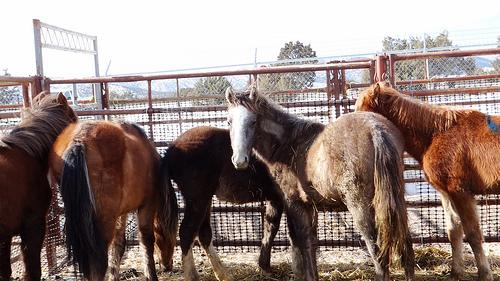Which horse has a unique mark on its back in the image? The horse with a blue mark on its back. Name two captioned colors seen on the horse in the image. Brown and white. What is the primary setting of the image, and what is the weather like? The primary setting is an enclosure with horses, and the weather is sunny with a clear sky. In the context of the image, describe what a referential expression grounding task could involve. A referential expression grounding task would involve identifying specific parts or features of the horses, such as their ears, eyes, tails, and legs, and grounding these expressions in the bounding box coordinates provided. If one would like to purchase a horse from the image, how would a product advertisement for a particular horse look like? Introducing our magnificent brown horse with a white face! This majestic creature is perfect for equestrian enthusiasts, featuring a distinct white nose and a charming demeanor. Don't miss out on this rare beauty. How many horses are in the image? There are four horses in the image. Determine whether the horses are well cared for by looking at the captions in the image. The horses seem to be well cared for, as they are described as eating hay and getting along well. Choose one of the horses from the captions and describe it in detail. One of the horses is a brown horse with a white face and a blue mark on its back. This horse has a white nose and stands in front of another horse and a fence. Identify the type of event where the horses might be present based on the image. The horses might be present at a horse rescue or rehabilitation center. Write a short poem about the horses in the image. Together standing, strong and high. 